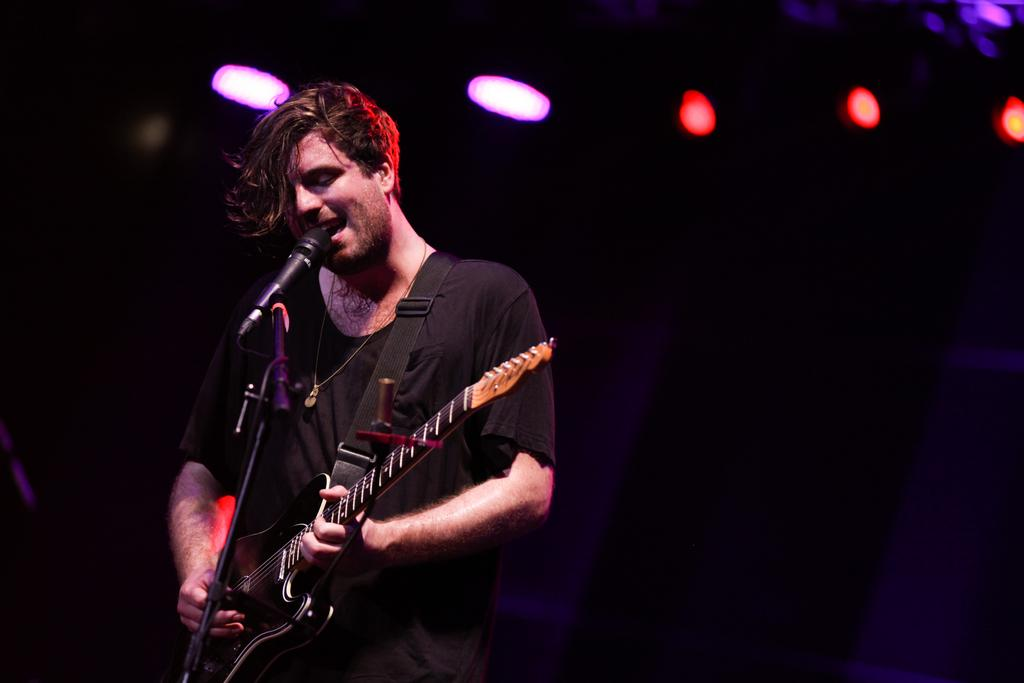What is the person in the image doing? The person is standing and playing a guitar. What object is in front of the person? There is a microphone in front of the person. What can be seen in the background of the image? There are lights in the background of the image. How many strangers are present in the image? There is no stranger present in the image; it only features a person playing a guitar. What type of bit is being used by the person in the image? There is no bit present in the image; the person is playing a guitar, which does not require a bit. 